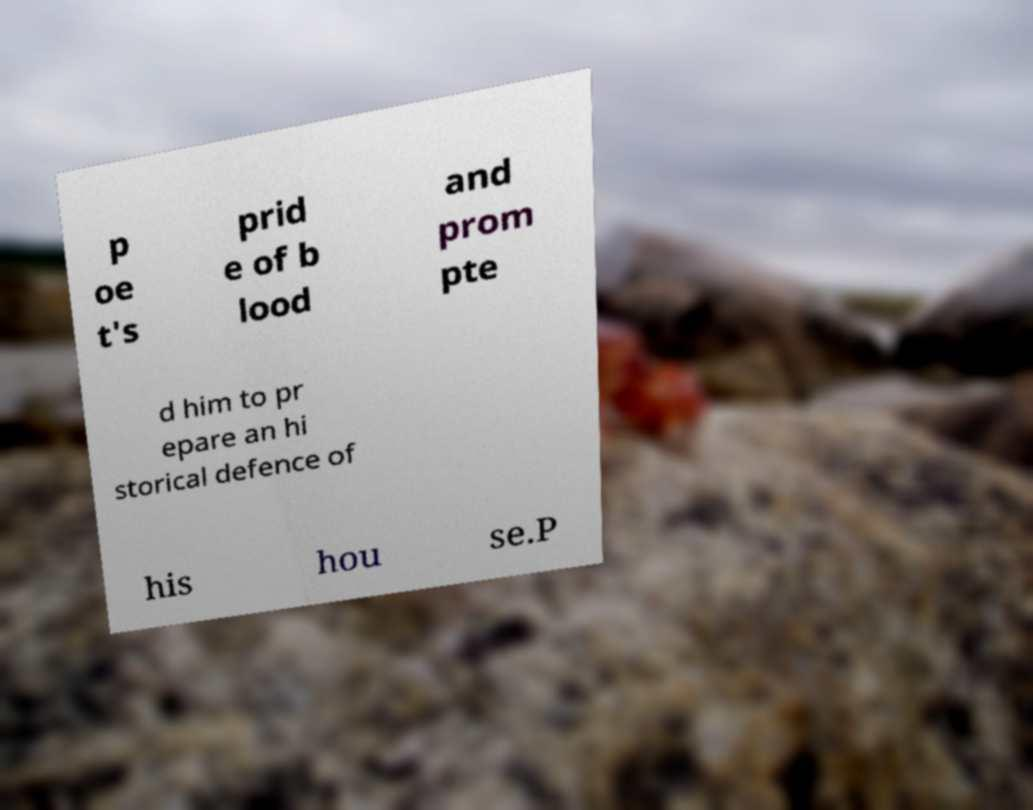Please read and relay the text visible in this image. What does it say? p oe t's prid e of b lood and prom pte d him to pr epare an hi storical defence of his hou se.P 